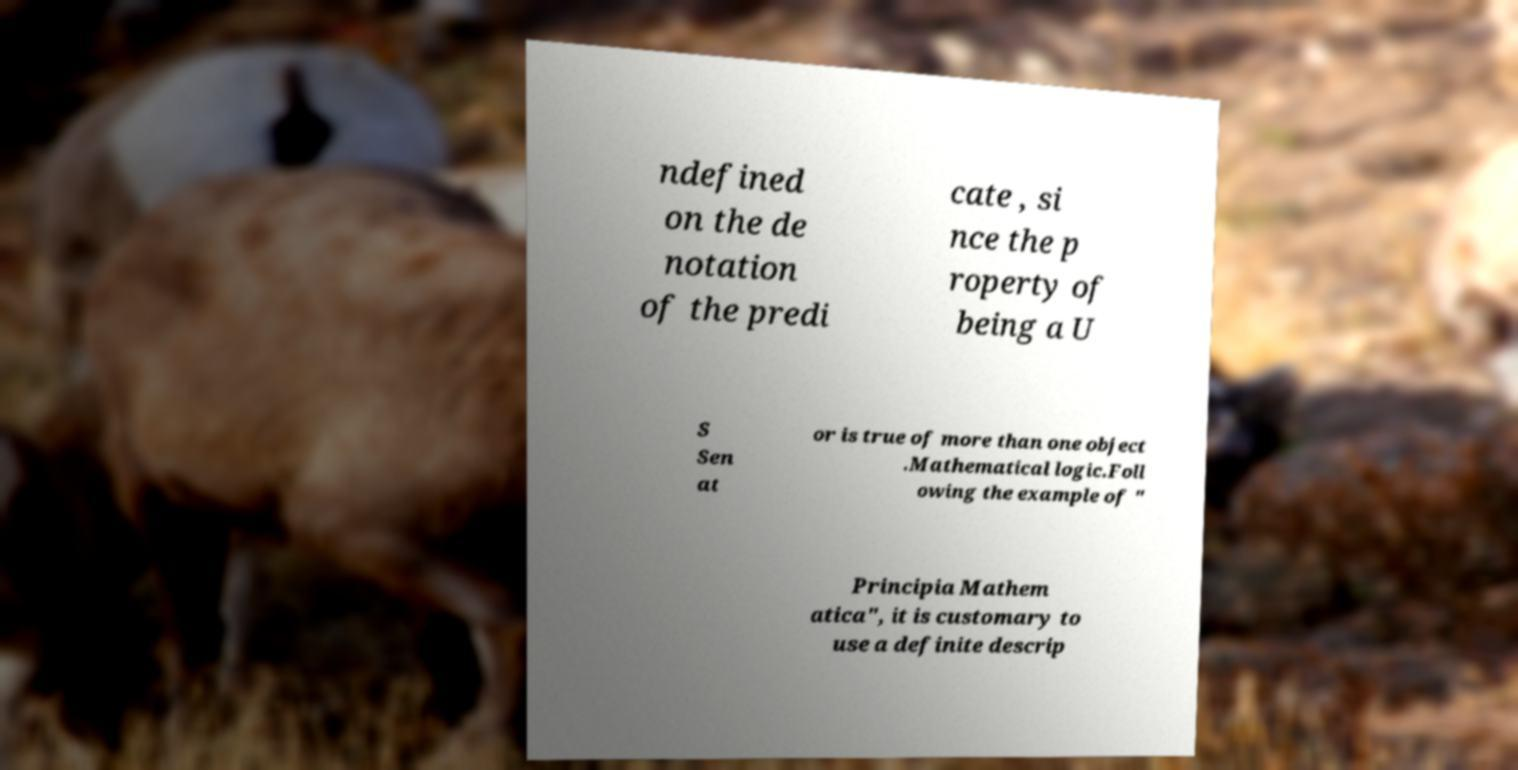Could you extract and type out the text from this image? ndefined on the de notation of the predi cate , si nce the p roperty of being a U S Sen at or is true of more than one object .Mathematical logic.Foll owing the example of " Principia Mathem atica", it is customary to use a definite descrip 